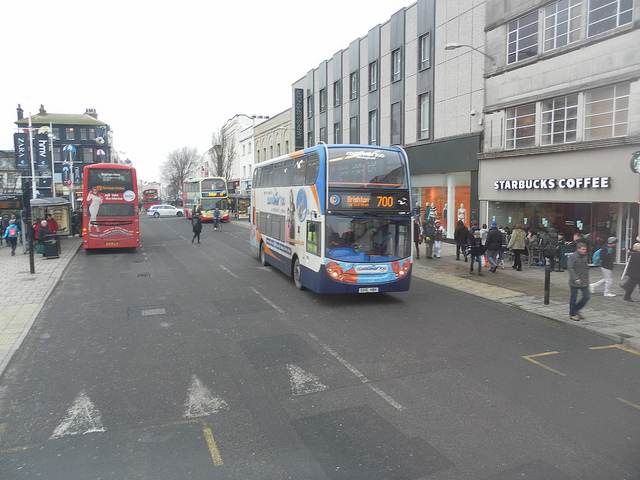Describe the architectural style of the buildings present. The buildings lining the street exhibit a blend of modern and commercial architectural styles. The structures on the right, particularly the one housing Starbucks Coffee, have a sleek and minimalist design, characterized by large windows and clean lines. The building materials appear to be concrete and glass, common in contemporary urban architecture. In contrast, the buildings farther back down the street display more historical features, suggesting a diverse architectural landscape within this urban setting. 